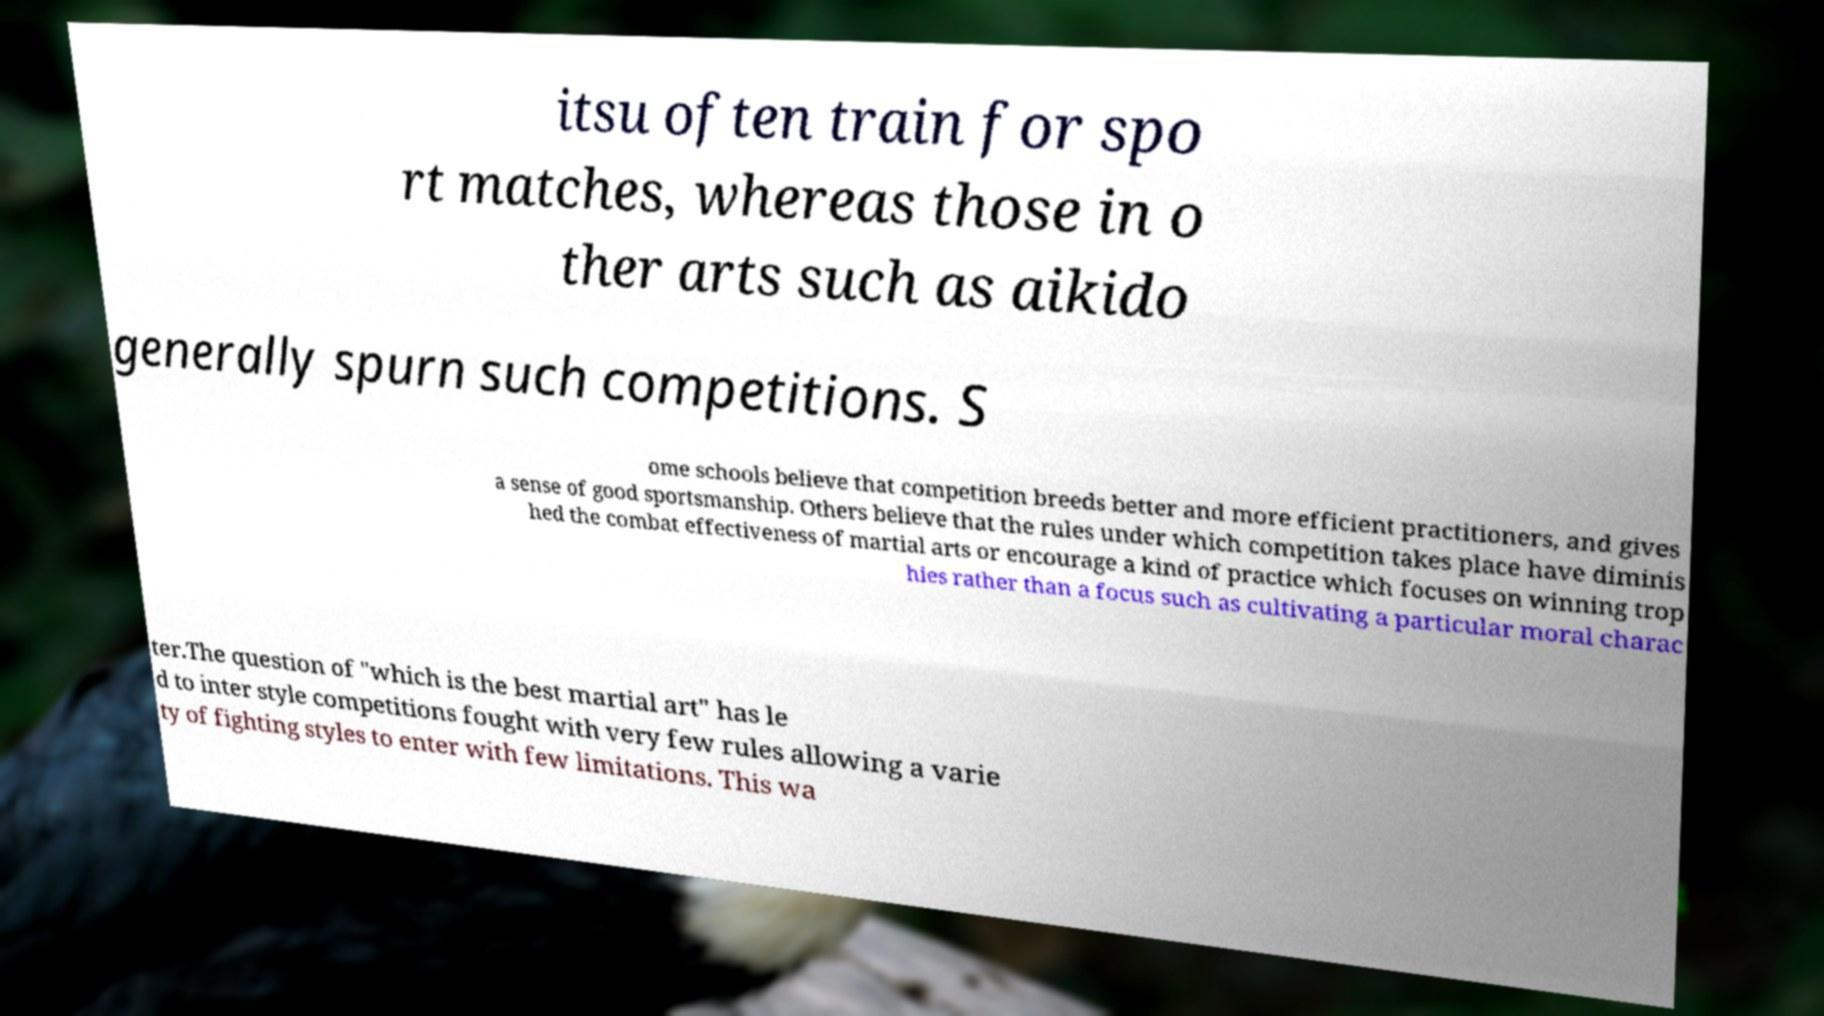I need the written content from this picture converted into text. Can you do that? itsu often train for spo rt matches, whereas those in o ther arts such as aikido generally spurn such competitions. S ome schools believe that competition breeds better and more efficient practitioners, and gives a sense of good sportsmanship. Others believe that the rules under which competition takes place have diminis hed the combat effectiveness of martial arts or encourage a kind of practice which focuses on winning trop hies rather than a focus such as cultivating a particular moral charac ter.The question of "which is the best martial art" has le d to inter style competitions fought with very few rules allowing a varie ty of fighting styles to enter with few limitations. This wa 